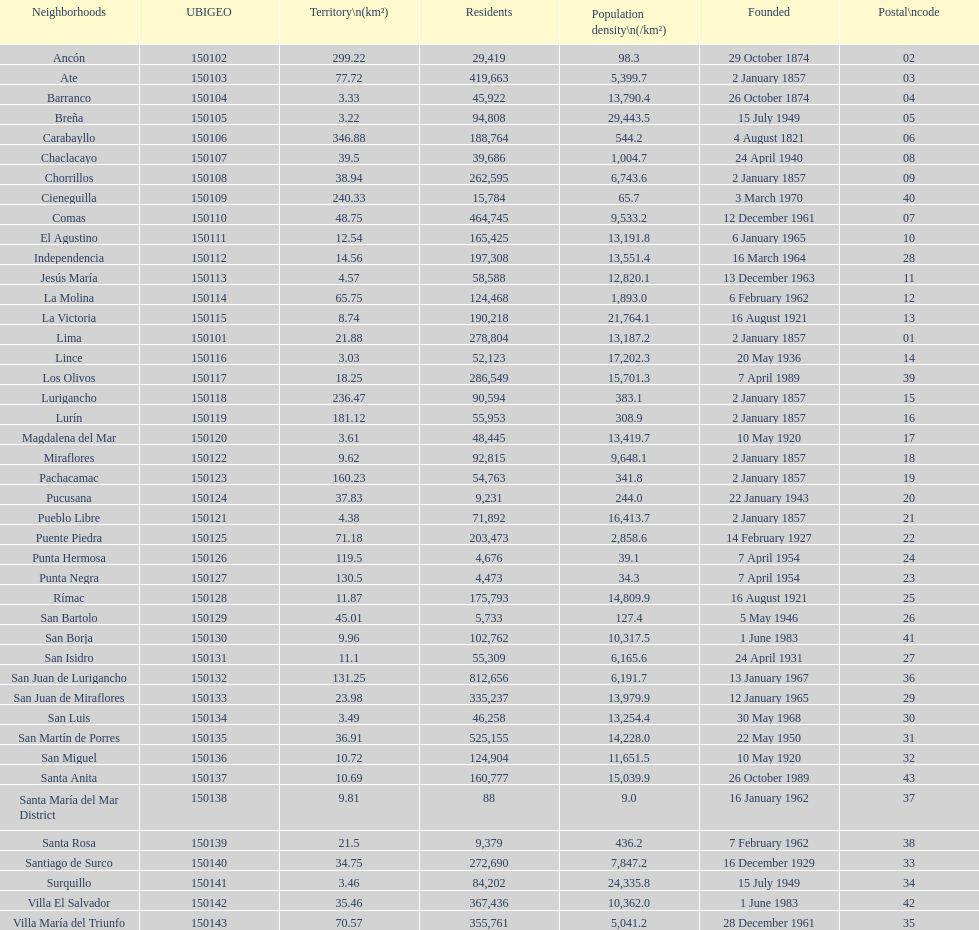What is the total number of districts created in the 1900's? 32. 